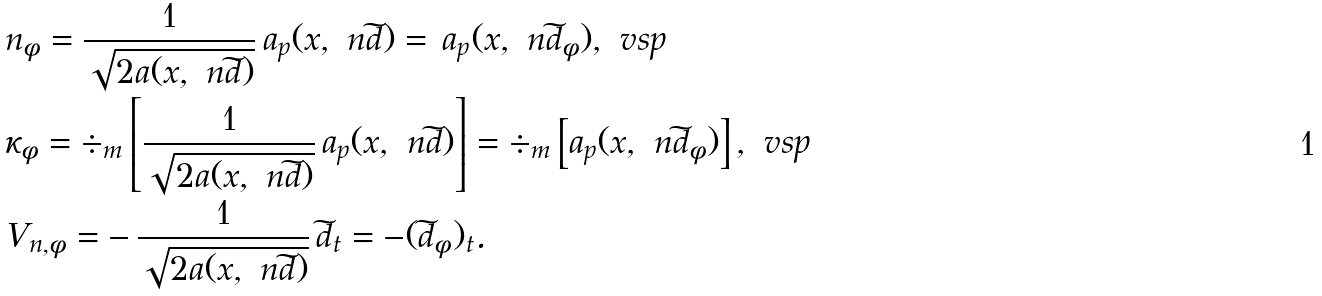Convert formula to latex. <formula><loc_0><loc_0><loc_500><loc_500>& n _ { \phi } = \frac { 1 } { \sqrt { 2 a ( x , \ n \widetilde { d } ) } } \, a _ { p } ( x , \ n \widetilde { d } ) = \, a _ { p } ( x , \ n \widetilde { d } _ { \phi } ) , \ v s p \\ & \kappa _ { \phi } = \div _ { m } \left [ \frac { 1 } { \sqrt { 2 a ( x , \ n \widetilde { d } ) } } \, a _ { p } ( x , \ n \widetilde { d } ) \right ] = \div _ { m } \left [ a _ { p } ( x , \ n \widetilde { d } _ { \phi } ) \right ] , \ v s p \\ & V _ { n , \phi } = - \, \frac { 1 } { \sqrt { 2 a ( x , \ n \widetilde { d } ) } } \, \widetilde { d } _ { t } = - ( \widetilde { d } _ { \phi } ) _ { t } .</formula> 